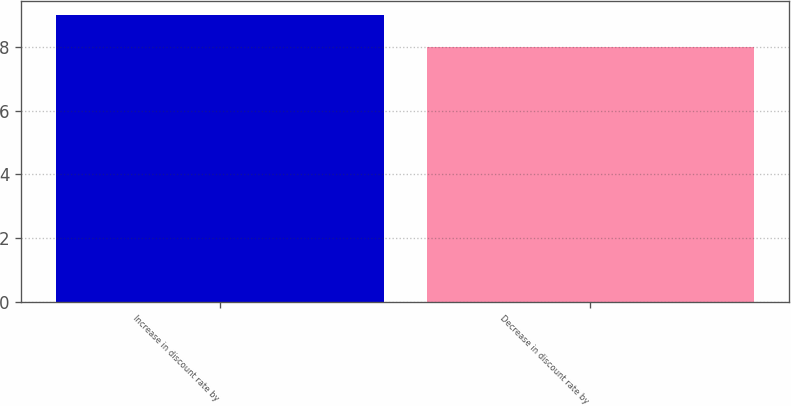Convert chart. <chart><loc_0><loc_0><loc_500><loc_500><bar_chart><fcel>Increase in discount rate by<fcel>Decrease in discount rate by<nl><fcel>9<fcel>8<nl></chart> 